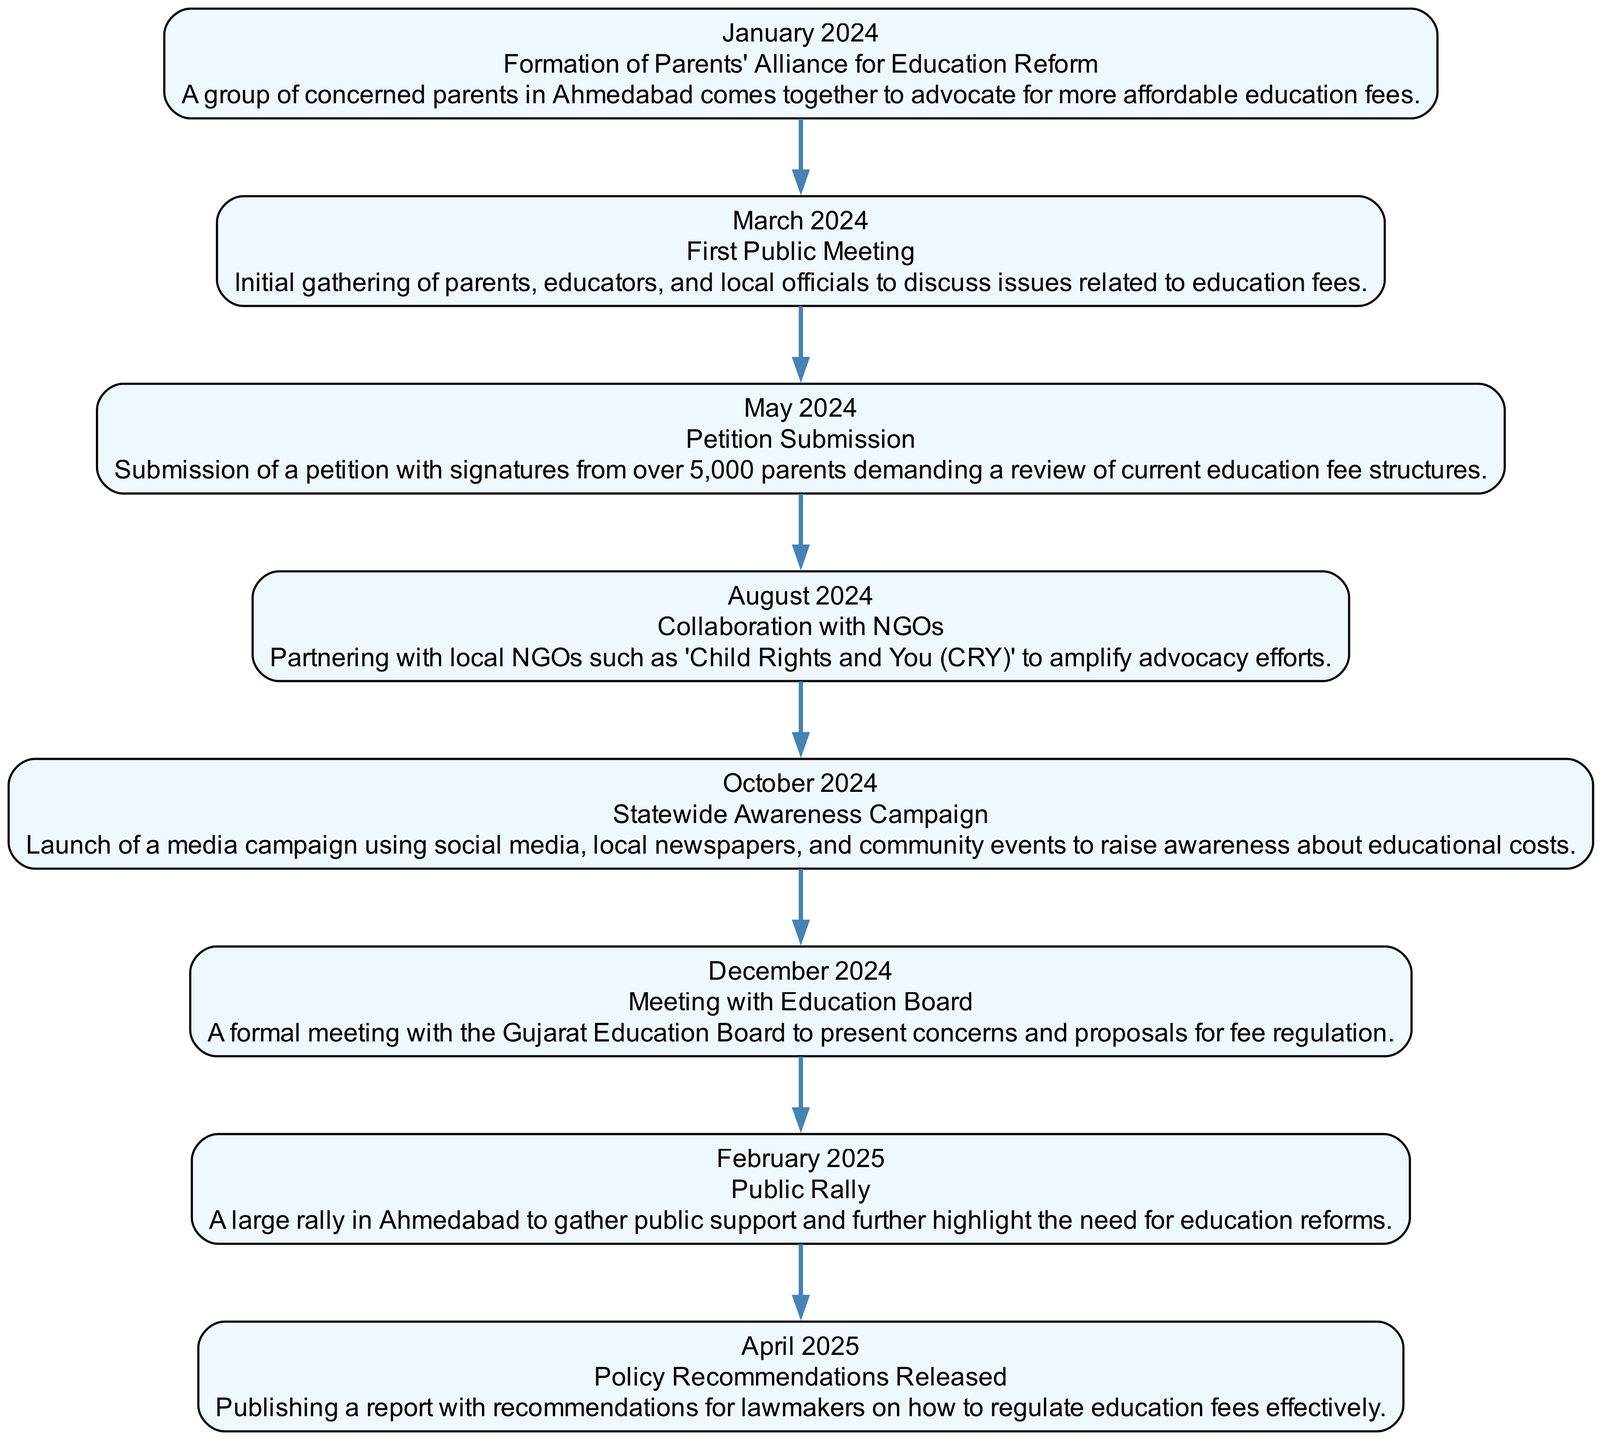What is the first event listed in the timeline? The first event in the diagram is "Formation of Parents' Alliance for Education Reform", which occurs in January 2024.
Answer: Formation of Parents' Alliance for Education Reform How many events are documented in the timeline? By counting the events listed in the diagram, there are a total of eight events from January 2024 to April 2025.
Answer: Eight What event takes place in March 2024? The event in March 2024 is "First Public Meeting", according to the diagram sequence.
Answer: First Public Meeting Which organization did the Parents' Alliance collaborate with in August 2024? The Parents' Alliance collaborated with local NGOs such as "Child Rights and You (CRY)" in August 2024 as shown in the timeline.
Answer: Child Rights and You (CRY) What is the main purpose of the event in December 2024? The purpose of the meeting in December 2024 is "to present concerns and proposals for fee regulation" to the Gujarat Education Board, as indicated in the event description.
Answer: Present concerns and proposals for fee regulation Which event immediately follows the Petition Submission? The event that follows "Petition Submission" in May 2024 is "Collaboration with NGOs" in August 2024, as we move through the timeline sequentially.
Answer: Collaboration with NGOs How many months were there between the First Public Meeting and the Petition Submission? The time from the First Public Meeting in March 2024 to the Petition Submission in May 2024 is two months apart.
Answer: Two months What key activity happens in February 2025? In February 2025, the key activity is the "Public Rally", as marked in the timeline.
Answer: Public Rally What is the final event in the timeline? The final event listed in the timeline is "Policy Recommendations Released" in April 2025, marking the conclusion of the advocacy campaign.
Answer: Policy Recommendations Released 